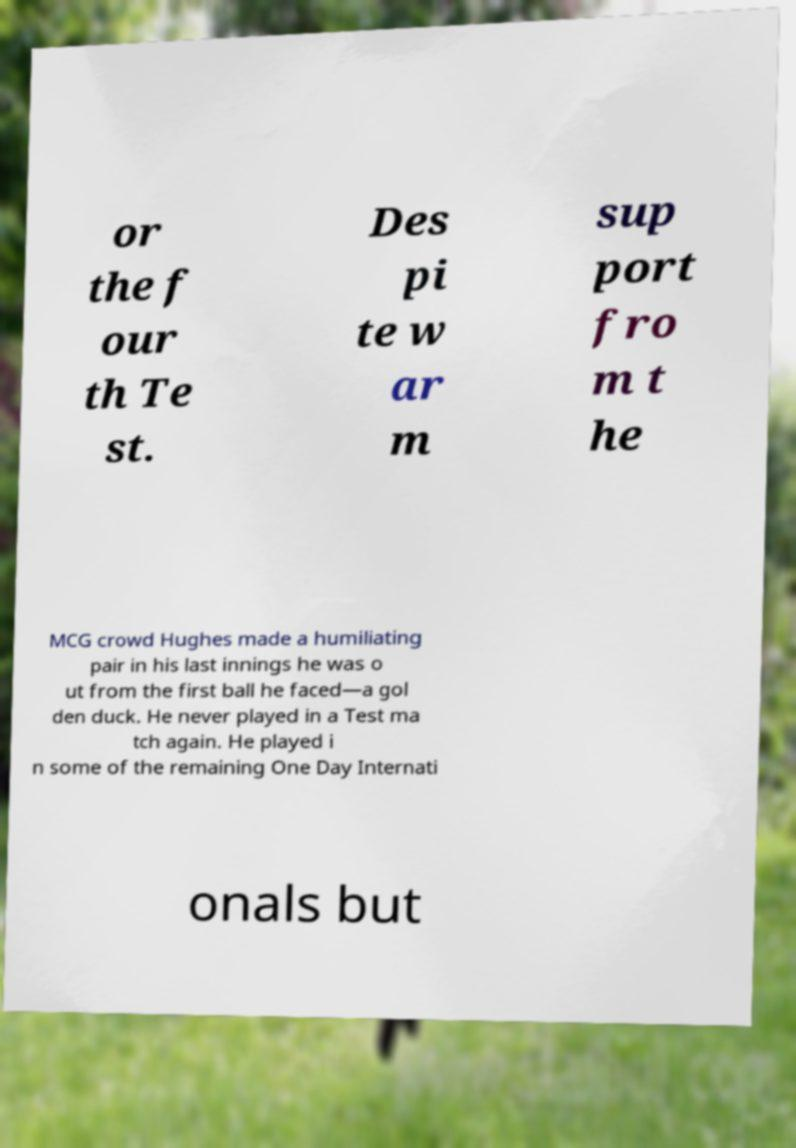Could you extract and type out the text from this image? or the f our th Te st. Des pi te w ar m sup port fro m t he MCG crowd Hughes made a humiliating pair in his last innings he was o ut from the first ball he faced—a gol den duck. He never played in a Test ma tch again. He played i n some of the remaining One Day Internati onals but 